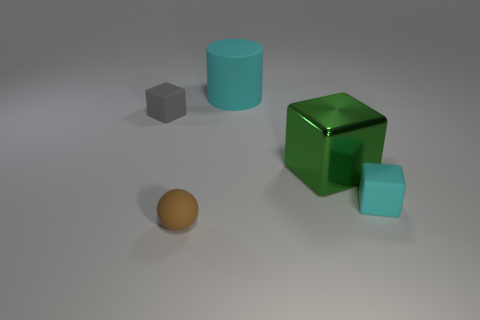Add 2 yellow cylinders. How many objects exist? 7 Subtract all spheres. How many objects are left? 4 Subtract all tiny brown metallic balls. Subtract all tiny cyan blocks. How many objects are left? 4 Add 5 big green metallic things. How many big green metallic things are left? 6 Add 3 small gray cubes. How many small gray cubes exist? 4 Subtract 1 brown spheres. How many objects are left? 4 